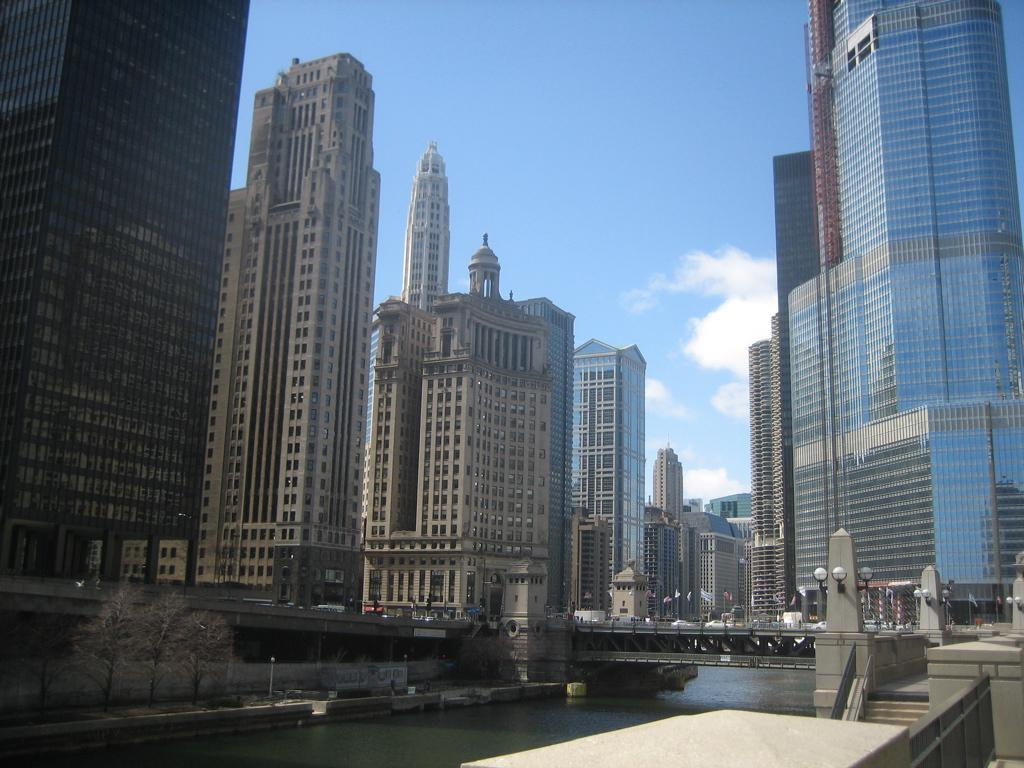What can be seen in the foreground of the image? In the foreground of the image, there is railing, stairs, and lights. What is visible in the background of the image? In the background of the image, there is a bridge, trees, a side path, skyscrapers, and the sky. Can you describe the sky in the image? The sky in the image is visible and has a cloud. What type of structure is present in the background of the image? There is a bridge in the background of the image. Can you tell me how many carts are being driven by the judge in the image? There are no carts or judges present in the image. What type of coach is visible on the side path in the image? There is no coach present on the side path in the image. 